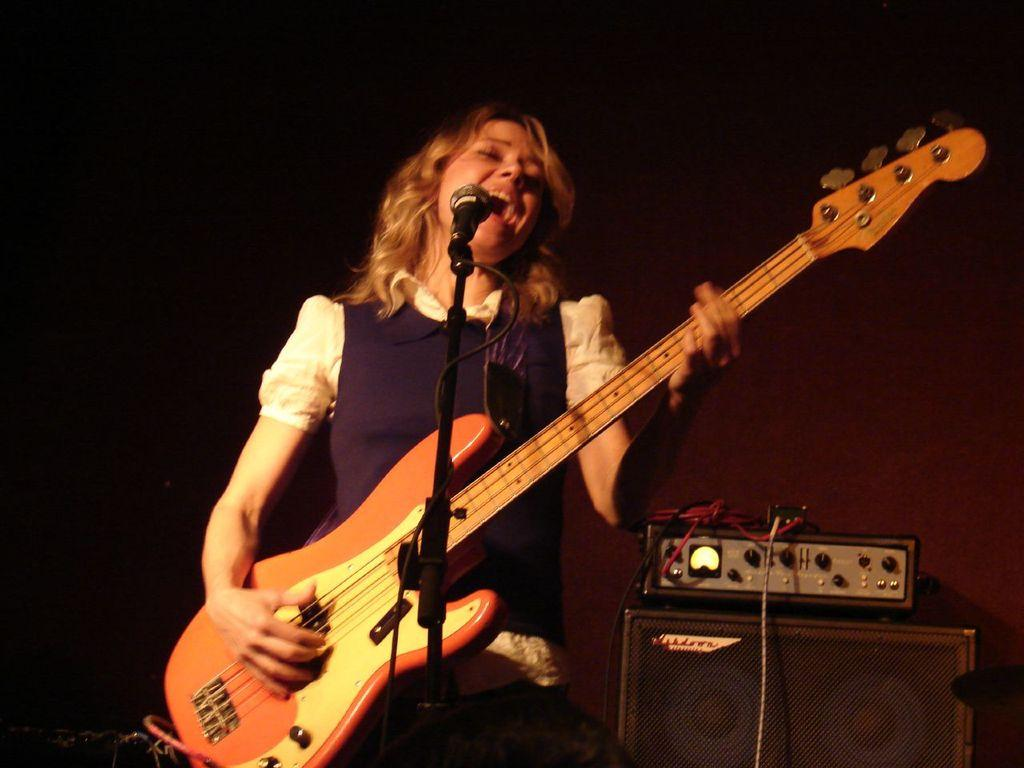Who is the main subject in the image? There is a woman in the image. What is the woman doing in the image? The woman is playing a guitar. What equipment is set up for the woman in the image? There is a microphone in front of the woman, a speaker on the right side of the image, and an amplifier on the right side of the image. What can be inferred about the lighting conditions in the image? The background of the image is dark. What type of powder is being used by the minister in the image? There is no minister or powder present in the image. How does the battle between the two armies affect the woman playing the guitar in the image? There is no battle or army present in the image; it features a woman playing a guitar with related equipment. 